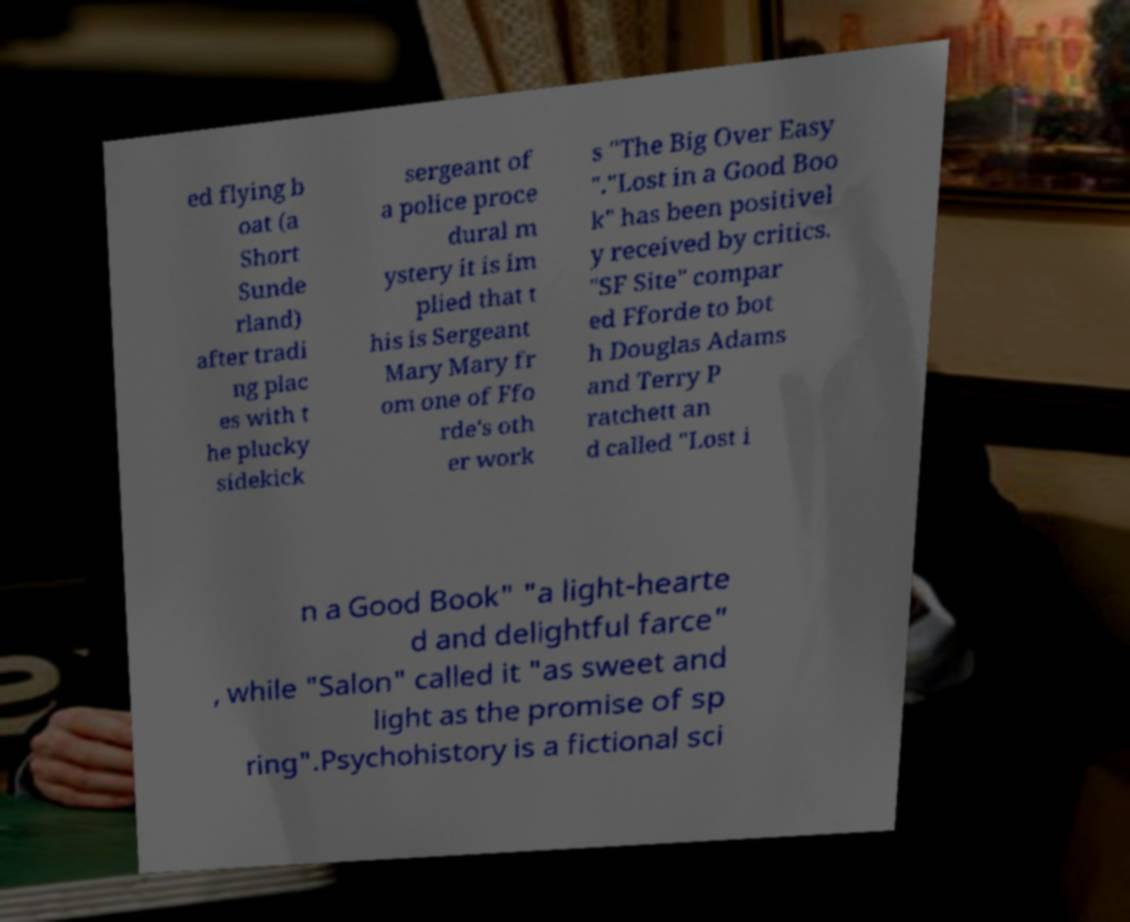Please read and relay the text visible in this image. What does it say? ed flying b oat (a Short Sunde rland) after tradi ng plac es with t he plucky sidekick sergeant of a police proce dural m ystery it is im plied that t his is Sergeant Mary Mary fr om one of Ffo rde's oth er work s "The Big Over Easy "."Lost in a Good Boo k" has been positivel y received by critics. "SF Site" compar ed Fforde to bot h Douglas Adams and Terry P ratchett an d called "Lost i n a Good Book" "a light-hearte d and delightful farce" , while "Salon" called it "as sweet and light as the promise of sp ring".Psychohistory is a fictional sci 